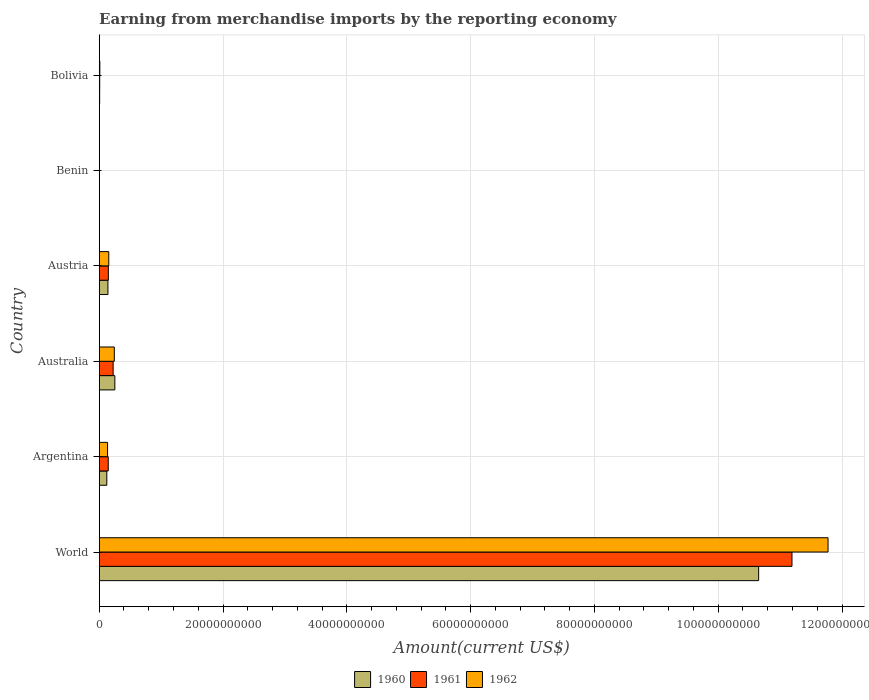How many different coloured bars are there?
Make the answer very short. 3. How many groups of bars are there?
Your answer should be very brief. 6. Are the number of bars per tick equal to the number of legend labels?
Your answer should be very brief. Yes. How many bars are there on the 2nd tick from the top?
Your answer should be very brief. 3. What is the amount earned from merchandise imports in 1961 in Argentina?
Your response must be concise. 1.46e+09. Across all countries, what is the maximum amount earned from merchandise imports in 1962?
Your answer should be very brief. 1.18e+11. Across all countries, what is the minimum amount earned from merchandise imports in 1962?
Provide a succinct answer. 2.38e+07. In which country was the amount earned from merchandise imports in 1961 maximum?
Provide a short and direct response. World. In which country was the amount earned from merchandise imports in 1962 minimum?
Offer a very short reply. Benin. What is the total amount earned from merchandise imports in 1961 in the graph?
Offer a very short reply. 1.17e+11. What is the difference between the amount earned from merchandise imports in 1961 in Benin and that in Bolivia?
Offer a terse response. -4.95e+07. What is the difference between the amount earned from merchandise imports in 1962 in Argentina and the amount earned from merchandise imports in 1960 in Bolivia?
Offer a very short reply. 1.28e+09. What is the average amount earned from merchandise imports in 1962 per country?
Offer a terse response. 2.05e+1. What is the difference between the amount earned from merchandise imports in 1962 and amount earned from merchandise imports in 1960 in Austria?
Ensure brevity in your answer.  1.36e+08. What is the ratio of the amount earned from merchandise imports in 1962 in Benin to that in World?
Offer a very short reply. 0. Is the difference between the amount earned from merchandise imports in 1962 in Bolivia and World greater than the difference between the amount earned from merchandise imports in 1960 in Bolivia and World?
Ensure brevity in your answer.  No. What is the difference between the highest and the second highest amount earned from merchandise imports in 1962?
Offer a terse response. 1.15e+11. What is the difference between the highest and the lowest amount earned from merchandise imports in 1962?
Your response must be concise. 1.18e+11. In how many countries, is the amount earned from merchandise imports in 1961 greater than the average amount earned from merchandise imports in 1961 taken over all countries?
Your answer should be compact. 1. What does the 1st bar from the top in Benin represents?
Offer a terse response. 1962. What does the 1st bar from the bottom in Australia represents?
Provide a succinct answer. 1960. Is it the case that in every country, the sum of the amount earned from merchandise imports in 1962 and amount earned from merchandise imports in 1961 is greater than the amount earned from merchandise imports in 1960?
Offer a very short reply. Yes. Are all the bars in the graph horizontal?
Your answer should be compact. Yes. What is the difference between two consecutive major ticks on the X-axis?
Your answer should be very brief. 2.00e+1. Does the graph contain any zero values?
Your answer should be very brief. No. How are the legend labels stacked?
Keep it short and to the point. Horizontal. What is the title of the graph?
Give a very brief answer. Earning from merchandise imports by the reporting economy. Does "2006" appear as one of the legend labels in the graph?
Make the answer very short. No. What is the label or title of the X-axis?
Offer a terse response. Amount(current US$). What is the Amount(current US$) in 1960 in World?
Your response must be concise. 1.07e+11. What is the Amount(current US$) in 1961 in World?
Make the answer very short. 1.12e+11. What is the Amount(current US$) of 1962 in World?
Your response must be concise. 1.18e+11. What is the Amount(current US$) in 1960 in Argentina?
Provide a succinct answer. 1.23e+09. What is the Amount(current US$) in 1961 in Argentina?
Keep it short and to the point. 1.46e+09. What is the Amount(current US$) of 1962 in Argentina?
Give a very brief answer. 1.35e+09. What is the Amount(current US$) in 1960 in Australia?
Offer a terse response. 2.52e+09. What is the Amount(current US$) of 1961 in Australia?
Ensure brevity in your answer.  2.25e+09. What is the Amount(current US$) in 1962 in Australia?
Your answer should be compact. 2.44e+09. What is the Amount(current US$) in 1960 in Austria?
Keep it short and to the point. 1.41e+09. What is the Amount(current US$) in 1961 in Austria?
Make the answer very short. 1.48e+09. What is the Amount(current US$) in 1962 in Austria?
Make the answer very short. 1.54e+09. What is the Amount(current US$) of 1960 in Benin?
Provide a short and direct response. 1.90e+06. What is the Amount(current US$) of 1961 in Benin?
Give a very brief answer. 2.81e+07. What is the Amount(current US$) in 1962 in Benin?
Your answer should be compact. 2.38e+07. What is the Amount(current US$) in 1960 in Bolivia?
Your answer should be compact. 7.11e+07. What is the Amount(current US$) in 1961 in Bolivia?
Give a very brief answer. 7.76e+07. What is the Amount(current US$) in 1962 in Bolivia?
Your answer should be compact. 9.79e+07. Across all countries, what is the maximum Amount(current US$) of 1960?
Your answer should be very brief. 1.07e+11. Across all countries, what is the maximum Amount(current US$) in 1961?
Provide a short and direct response. 1.12e+11. Across all countries, what is the maximum Amount(current US$) in 1962?
Your answer should be compact. 1.18e+11. Across all countries, what is the minimum Amount(current US$) of 1960?
Keep it short and to the point. 1.90e+06. Across all countries, what is the minimum Amount(current US$) of 1961?
Ensure brevity in your answer.  2.81e+07. Across all countries, what is the minimum Amount(current US$) of 1962?
Provide a short and direct response. 2.38e+07. What is the total Amount(current US$) of 1960 in the graph?
Your answer should be compact. 1.12e+11. What is the total Amount(current US$) in 1961 in the graph?
Your answer should be very brief. 1.17e+11. What is the total Amount(current US$) in 1962 in the graph?
Provide a short and direct response. 1.23e+11. What is the difference between the Amount(current US$) in 1960 in World and that in Argentina?
Give a very brief answer. 1.05e+11. What is the difference between the Amount(current US$) of 1961 in World and that in Argentina?
Your answer should be very brief. 1.10e+11. What is the difference between the Amount(current US$) in 1962 in World and that in Argentina?
Give a very brief answer. 1.16e+11. What is the difference between the Amount(current US$) in 1960 in World and that in Australia?
Your answer should be compact. 1.04e+11. What is the difference between the Amount(current US$) of 1961 in World and that in Australia?
Ensure brevity in your answer.  1.10e+11. What is the difference between the Amount(current US$) in 1962 in World and that in Australia?
Your answer should be very brief. 1.15e+11. What is the difference between the Amount(current US$) in 1960 in World and that in Austria?
Your answer should be very brief. 1.05e+11. What is the difference between the Amount(current US$) in 1961 in World and that in Austria?
Offer a terse response. 1.10e+11. What is the difference between the Amount(current US$) in 1962 in World and that in Austria?
Make the answer very short. 1.16e+11. What is the difference between the Amount(current US$) of 1960 in World and that in Benin?
Provide a short and direct response. 1.07e+11. What is the difference between the Amount(current US$) of 1961 in World and that in Benin?
Give a very brief answer. 1.12e+11. What is the difference between the Amount(current US$) of 1962 in World and that in Benin?
Offer a very short reply. 1.18e+11. What is the difference between the Amount(current US$) in 1960 in World and that in Bolivia?
Keep it short and to the point. 1.06e+11. What is the difference between the Amount(current US$) in 1961 in World and that in Bolivia?
Your answer should be very brief. 1.12e+11. What is the difference between the Amount(current US$) of 1962 in World and that in Bolivia?
Ensure brevity in your answer.  1.18e+11. What is the difference between the Amount(current US$) in 1960 in Argentina and that in Australia?
Your answer should be very brief. -1.30e+09. What is the difference between the Amount(current US$) of 1961 in Argentina and that in Australia?
Provide a succinct answer. -7.89e+08. What is the difference between the Amount(current US$) of 1962 in Argentina and that in Australia?
Offer a very short reply. -1.09e+09. What is the difference between the Amount(current US$) in 1960 in Argentina and that in Austria?
Offer a terse response. -1.82e+08. What is the difference between the Amount(current US$) in 1961 in Argentina and that in Austria?
Ensure brevity in your answer.  -1.66e+07. What is the difference between the Amount(current US$) of 1962 in Argentina and that in Austria?
Your answer should be very brief. -1.97e+08. What is the difference between the Amount(current US$) in 1960 in Argentina and that in Benin?
Offer a very short reply. 1.23e+09. What is the difference between the Amount(current US$) of 1961 in Argentina and that in Benin?
Offer a terse response. 1.43e+09. What is the difference between the Amount(current US$) of 1962 in Argentina and that in Benin?
Offer a very short reply. 1.32e+09. What is the difference between the Amount(current US$) of 1960 in Argentina and that in Bolivia?
Provide a short and direct response. 1.16e+09. What is the difference between the Amount(current US$) of 1961 in Argentina and that in Bolivia?
Give a very brief answer. 1.38e+09. What is the difference between the Amount(current US$) of 1962 in Argentina and that in Bolivia?
Make the answer very short. 1.25e+09. What is the difference between the Amount(current US$) in 1960 in Australia and that in Austria?
Give a very brief answer. 1.12e+09. What is the difference between the Amount(current US$) in 1961 in Australia and that in Austria?
Ensure brevity in your answer.  7.72e+08. What is the difference between the Amount(current US$) of 1962 in Australia and that in Austria?
Make the answer very short. 8.94e+08. What is the difference between the Amount(current US$) in 1960 in Australia and that in Benin?
Provide a short and direct response. 2.52e+09. What is the difference between the Amount(current US$) of 1961 in Australia and that in Benin?
Make the answer very short. 2.22e+09. What is the difference between the Amount(current US$) of 1962 in Australia and that in Benin?
Make the answer very short. 2.41e+09. What is the difference between the Amount(current US$) of 1960 in Australia and that in Bolivia?
Your answer should be compact. 2.45e+09. What is the difference between the Amount(current US$) of 1961 in Australia and that in Bolivia?
Keep it short and to the point. 2.17e+09. What is the difference between the Amount(current US$) of 1962 in Australia and that in Bolivia?
Provide a succinct answer. 2.34e+09. What is the difference between the Amount(current US$) of 1960 in Austria and that in Benin?
Your answer should be compact. 1.41e+09. What is the difference between the Amount(current US$) of 1961 in Austria and that in Benin?
Ensure brevity in your answer.  1.45e+09. What is the difference between the Amount(current US$) in 1962 in Austria and that in Benin?
Your response must be concise. 1.52e+09. What is the difference between the Amount(current US$) in 1960 in Austria and that in Bolivia?
Keep it short and to the point. 1.34e+09. What is the difference between the Amount(current US$) of 1961 in Austria and that in Bolivia?
Keep it short and to the point. 1.40e+09. What is the difference between the Amount(current US$) in 1962 in Austria and that in Bolivia?
Ensure brevity in your answer.  1.45e+09. What is the difference between the Amount(current US$) in 1960 in Benin and that in Bolivia?
Your answer should be very brief. -6.92e+07. What is the difference between the Amount(current US$) of 1961 in Benin and that in Bolivia?
Your answer should be compact. -4.95e+07. What is the difference between the Amount(current US$) of 1962 in Benin and that in Bolivia?
Your response must be concise. -7.41e+07. What is the difference between the Amount(current US$) in 1960 in World and the Amount(current US$) in 1961 in Argentina?
Your response must be concise. 1.05e+11. What is the difference between the Amount(current US$) of 1960 in World and the Amount(current US$) of 1962 in Argentina?
Provide a short and direct response. 1.05e+11. What is the difference between the Amount(current US$) of 1961 in World and the Amount(current US$) of 1962 in Argentina?
Your answer should be compact. 1.11e+11. What is the difference between the Amount(current US$) of 1960 in World and the Amount(current US$) of 1961 in Australia?
Provide a short and direct response. 1.04e+11. What is the difference between the Amount(current US$) in 1960 in World and the Amount(current US$) in 1962 in Australia?
Your answer should be compact. 1.04e+11. What is the difference between the Amount(current US$) in 1961 in World and the Amount(current US$) in 1962 in Australia?
Offer a very short reply. 1.09e+11. What is the difference between the Amount(current US$) of 1960 in World and the Amount(current US$) of 1961 in Austria?
Give a very brief answer. 1.05e+11. What is the difference between the Amount(current US$) of 1960 in World and the Amount(current US$) of 1962 in Austria?
Your response must be concise. 1.05e+11. What is the difference between the Amount(current US$) of 1961 in World and the Amount(current US$) of 1962 in Austria?
Keep it short and to the point. 1.10e+11. What is the difference between the Amount(current US$) of 1960 in World and the Amount(current US$) of 1961 in Benin?
Ensure brevity in your answer.  1.07e+11. What is the difference between the Amount(current US$) of 1960 in World and the Amount(current US$) of 1962 in Benin?
Offer a terse response. 1.07e+11. What is the difference between the Amount(current US$) of 1961 in World and the Amount(current US$) of 1962 in Benin?
Offer a terse response. 1.12e+11. What is the difference between the Amount(current US$) of 1960 in World and the Amount(current US$) of 1961 in Bolivia?
Keep it short and to the point. 1.06e+11. What is the difference between the Amount(current US$) of 1960 in World and the Amount(current US$) of 1962 in Bolivia?
Your response must be concise. 1.06e+11. What is the difference between the Amount(current US$) in 1961 in World and the Amount(current US$) in 1962 in Bolivia?
Provide a succinct answer. 1.12e+11. What is the difference between the Amount(current US$) in 1960 in Argentina and the Amount(current US$) in 1961 in Australia?
Keep it short and to the point. -1.02e+09. What is the difference between the Amount(current US$) of 1960 in Argentina and the Amount(current US$) of 1962 in Australia?
Provide a succinct answer. -1.21e+09. What is the difference between the Amount(current US$) in 1961 in Argentina and the Amount(current US$) in 1962 in Australia?
Give a very brief answer. -9.78e+08. What is the difference between the Amount(current US$) in 1960 in Argentina and the Amount(current US$) in 1961 in Austria?
Your answer should be compact. -2.50e+08. What is the difference between the Amount(current US$) of 1960 in Argentina and the Amount(current US$) of 1962 in Austria?
Make the answer very short. -3.17e+08. What is the difference between the Amount(current US$) in 1961 in Argentina and the Amount(current US$) in 1962 in Austria?
Keep it short and to the point. -8.41e+07. What is the difference between the Amount(current US$) in 1960 in Argentina and the Amount(current US$) in 1961 in Benin?
Make the answer very short. 1.20e+09. What is the difference between the Amount(current US$) in 1960 in Argentina and the Amount(current US$) in 1962 in Benin?
Provide a short and direct response. 1.20e+09. What is the difference between the Amount(current US$) in 1961 in Argentina and the Amount(current US$) in 1962 in Benin?
Your answer should be compact. 1.44e+09. What is the difference between the Amount(current US$) of 1960 in Argentina and the Amount(current US$) of 1961 in Bolivia?
Your response must be concise. 1.15e+09. What is the difference between the Amount(current US$) in 1960 in Argentina and the Amount(current US$) in 1962 in Bolivia?
Your answer should be compact. 1.13e+09. What is the difference between the Amount(current US$) of 1961 in Argentina and the Amount(current US$) of 1962 in Bolivia?
Offer a very short reply. 1.36e+09. What is the difference between the Amount(current US$) in 1960 in Australia and the Amount(current US$) in 1961 in Austria?
Your response must be concise. 1.05e+09. What is the difference between the Amount(current US$) in 1960 in Australia and the Amount(current US$) in 1962 in Austria?
Keep it short and to the point. 9.80e+08. What is the difference between the Amount(current US$) in 1961 in Australia and the Amount(current US$) in 1962 in Austria?
Provide a short and direct response. 7.05e+08. What is the difference between the Amount(current US$) in 1960 in Australia and the Amount(current US$) in 1961 in Benin?
Ensure brevity in your answer.  2.50e+09. What is the difference between the Amount(current US$) of 1960 in Australia and the Amount(current US$) of 1962 in Benin?
Keep it short and to the point. 2.50e+09. What is the difference between the Amount(current US$) of 1961 in Australia and the Amount(current US$) of 1962 in Benin?
Your answer should be very brief. 2.23e+09. What is the difference between the Amount(current US$) in 1960 in Australia and the Amount(current US$) in 1961 in Bolivia?
Your answer should be compact. 2.45e+09. What is the difference between the Amount(current US$) in 1960 in Australia and the Amount(current US$) in 1962 in Bolivia?
Make the answer very short. 2.43e+09. What is the difference between the Amount(current US$) in 1961 in Australia and the Amount(current US$) in 1962 in Bolivia?
Offer a very short reply. 2.15e+09. What is the difference between the Amount(current US$) of 1960 in Austria and the Amount(current US$) of 1961 in Benin?
Offer a terse response. 1.38e+09. What is the difference between the Amount(current US$) of 1960 in Austria and the Amount(current US$) of 1962 in Benin?
Make the answer very short. 1.38e+09. What is the difference between the Amount(current US$) of 1961 in Austria and the Amount(current US$) of 1962 in Benin?
Provide a short and direct response. 1.45e+09. What is the difference between the Amount(current US$) of 1960 in Austria and the Amount(current US$) of 1961 in Bolivia?
Offer a very short reply. 1.33e+09. What is the difference between the Amount(current US$) of 1960 in Austria and the Amount(current US$) of 1962 in Bolivia?
Offer a very short reply. 1.31e+09. What is the difference between the Amount(current US$) of 1961 in Austria and the Amount(current US$) of 1962 in Bolivia?
Keep it short and to the point. 1.38e+09. What is the difference between the Amount(current US$) in 1960 in Benin and the Amount(current US$) in 1961 in Bolivia?
Offer a very short reply. -7.57e+07. What is the difference between the Amount(current US$) in 1960 in Benin and the Amount(current US$) in 1962 in Bolivia?
Give a very brief answer. -9.60e+07. What is the difference between the Amount(current US$) of 1961 in Benin and the Amount(current US$) of 1962 in Bolivia?
Keep it short and to the point. -6.98e+07. What is the average Amount(current US$) in 1960 per country?
Provide a succinct answer. 1.86e+1. What is the average Amount(current US$) in 1961 per country?
Keep it short and to the point. 1.95e+1. What is the average Amount(current US$) in 1962 per country?
Offer a very short reply. 2.05e+1. What is the difference between the Amount(current US$) in 1960 and Amount(current US$) in 1961 in World?
Ensure brevity in your answer.  -5.38e+09. What is the difference between the Amount(current US$) in 1960 and Amount(current US$) in 1962 in World?
Keep it short and to the point. -1.12e+1. What is the difference between the Amount(current US$) of 1961 and Amount(current US$) of 1962 in World?
Provide a short and direct response. -5.83e+09. What is the difference between the Amount(current US$) in 1960 and Amount(current US$) in 1961 in Argentina?
Ensure brevity in your answer.  -2.33e+08. What is the difference between the Amount(current US$) of 1960 and Amount(current US$) of 1962 in Argentina?
Your answer should be compact. -1.20e+08. What is the difference between the Amount(current US$) in 1961 and Amount(current US$) in 1962 in Argentina?
Provide a short and direct response. 1.13e+08. What is the difference between the Amount(current US$) in 1960 and Amount(current US$) in 1961 in Australia?
Give a very brief answer. 2.75e+08. What is the difference between the Amount(current US$) of 1960 and Amount(current US$) of 1962 in Australia?
Provide a short and direct response. 8.57e+07. What is the difference between the Amount(current US$) of 1961 and Amount(current US$) of 1962 in Australia?
Offer a terse response. -1.89e+08. What is the difference between the Amount(current US$) of 1960 and Amount(current US$) of 1961 in Austria?
Provide a succinct answer. -6.82e+07. What is the difference between the Amount(current US$) of 1960 and Amount(current US$) of 1962 in Austria?
Ensure brevity in your answer.  -1.36e+08. What is the difference between the Amount(current US$) in 1961 and Amount(current US$) in 1962 in Austria?
Keep it short and to the point. -6.75e+07. What is the difference between the Amount(current US$) in 1960 and Amount(current US$) in 1961 in Benin?
Your answer should be compact. -2.62e+07. What is the difference between the Amount(current US$) in 1960 and Amount(current US$) in 1962 in Benin?
Keep it short and to the point. -2.19e+07. What is the difference between the Amount(current US$) in 1961 and Amount(current US$) in 1962 in Benin?
Offer a terse response. 4.30e+06. What is the difference between the Amount(current US$) of 1960 and Amount(current US$) of 1961 in Bolivia?
Keep it short and to the point. -6.50e+06. What is the difference between the Amount(current US$) of 1960 and Amount(current US$) of 1962 in Bolivia?
Your answer should be compact. -2.68e+07. What is the difference between the Amount(current US$) of 1961 and Amount(current US$) of 1962 in Bolivia?
Provide a short and direct response. -2.03e+07. What is the ratio of the Amount(current US$) of 1960 in World to that in Argentina?
Provide a succinct answer. 86.8. What is the ratio of the Amount(current US$) of 1961 in World to that in Argentina?
Your answer should be very brief. 76.63. What is the ratio of the Amount(current US$) in 1962 in World to that in Argentina?
Your response must be concise. 87.41. What is the ratio of the Amount(current US$) in 1960 in World to that in Australia?
Your response must be concise. 42.21. What is the ratio of the Amount(current US$) of 1961 in World to that in Australia?
Provide a succinct answer. 49.76. What is the ratio of the Amount(current US$) of 1962 in World to that in Australia?
Keep it short and to the point. 48.29. What is the ratio of the Amount(current US$) of 1960 in World to that in Austria?
Ensure brevity in your answer.  75.62. What is the ratio of the Amount(current US$) in 1961 in World to that in Austria?
Your response must be concise. 75.77. What is the ratio of the Amount(current US$) of 1962 in World to that in Austria?
Offer a terse response. 76.23. What is the ratio of the Amount(current US$) in 1960 in World to that in Benin?
Offer a very short reply. 5.61e+04. What is the ratio of the Amount(current US$) in 1961 in World to that in Benin?
Your answer should be compact. 3982.78. What is the ratio of the Amount(current US$) in 1962 in World to that in Benin?
Provide a succinct answer. 4947.22. What is the ratio of the Amount(current US$) in 1960 in World to that in Bolivia?
Your answer should be very brief. 1498.35. What is the ratio of the Amount(current US$) of 1961 in World to that in Bolivia?
Give a very brief answer. 1442.22. What is the ratio of the Amount(current US$) in 1962 in World to that in Bolivia?
Your answer should be compact. 1202.69. What is the ratio of the Amount(current US$) in 1960 in Argentina to that in Australia?
Offer a very short reply. 0.49. What is the ratio of the Amount(current US$) in 1961 in Argentina to that in Australia?
Keep it short and to the point. 0.65. What is the ratio of the Amount(current US$) of 1962 in Argentina to that in Australia?
Offer a very short reply. 0.55. What is the ratio of the Amount(current US$) in 1960 in Argentina to that in Austria?
Keep it short and to the point. 0.87. What is the ratio of the Amount(current US$) of 1961 in Argentina to that in Austria?
Make the answer very short. 0.99. What is the ratio of the Amount(current US$) in 1962 in Argentina to that in Austria?
Your response must be concise. 0.87. What is the ratio of the Amount(current US$) in 1960 in Argentina to that in Benin?
Ensure brevity in your answer.  645.95. What is the ratio of the Amount(current US$) of 1961 in Argentina to that in Benin?
Keep it short and to the point. 51.97. What is the ratio of the Amount(current US$) of 1962 in Argentina to that in Benin?
Provide a short and direct response. 56.6. What is the ratio of the Amount(current US$) of 1960 in Argentina to that in Bolivia?
Keep it short and to the point. 17.26. What is the ratio of the Amount(current US$) of 1961 in Argentina to that in Bolivia?
Keep it short and to the point. 18.82. What is the ratio of the Amount(current US$) of 1962 in Argentina to that in Bolivia?
Offer a very short reply. 13.76. What is the ratio of the Amount(current US$) in 1960 in Australia to that in Austria?
Make the answer very short. 1.79. What is the ratio of the Amount(current US$) of 1961 in Australia to that in Austria?
Give a very brief answer. 1.52. What is the ratio of the Amount(current US$) of 1962 in Australia to that in Austria?
Your response must be concise. 1.58. What is the ratio of the Amount(current US$) in 1960 in Australia to that in Benin?
Give a very brief answer. 1328.45. What is the ratio of the Amount(current US$) in 1961 in Australia to that in Benin?
Provide a short and direct response. 80.04. What is the ratio of the Amount(current US$) of 1962 in Australia to that in Benin?
Provide a short and direct response. 102.45. What is the ratio of the Amount(current US$) of 1960 in Australia to that in Bolivia?
Make the answer very short. 35.5. What is the ratio of the Amount(current US$) in 1961 in Australia to that in Bolivia?
Keep it short and to the point. 28.98. What is the ratio of the Amount(current US$) in 1962 in Australia to that in Bolivia?
Offer a terse response. 24.91. What is the ratio of the Amount(current US$) in 1960 in Austria to that in Benin?
Ensure brevity in your answer.  741.47. What is the ratio of the Amount(current US$) of 1961 in Austria to that in Benin?
Your response must be concise. 52.56. What is the ratio of the Amount(current US$) of 1962 in Austria to that in Benin?
Provide a short and direct response. 64.89. What is the ratio of the Amount(current US$) in 1960 in Austria to that in Bolivia?
Your response must be concise. 19.81. What is the ratio of the Amount(current US$) of 1961 in Austria to that in Bolivia?
Provide a succinct answer. 19.03. What is the ratio of the Amount(current US$) in 1962 in Austria to that in Bolivia?
Keep it short and to the point. 15.78. What is the ratio of the Amount(current US$) of 1960 in Benin to that in Bolivia?
Your answer should be compact. 0.03. What is the ratio of the Amount(current US$) of 1961 in Benin to that in Bolivia?
Provide a short and direct response. 0.36. What is the ratio of the Amount(current US$) in 1962 in Benin to that in Bolivia?
Provide a short and direct response. 0.24. What is the difference between the highest and the second highest Amount(current US$) of 1960?
Your answer should be compact. 1.04e+11. What is the difference between the highest and the second highest Amount(current US$) in 1961?
Provide a succinct answer. 1.10e+11. What is the difference between the highest and the second highest Amount(current US$) in 1962?
Your answer should be compact. 1.15e+11. What is the difference between the highest and the lowest Amount(current US$) in 1960?
Offer a terse response. 1.07e+11. What is the difference between the highest and the lowest Amount(current US$) in 1961?
Make the answer very short. 1.12e+11. What is the difference between the highest and the lowest Amount(current US$) of 1962?
Make the answer very short. 1.18e+11. 